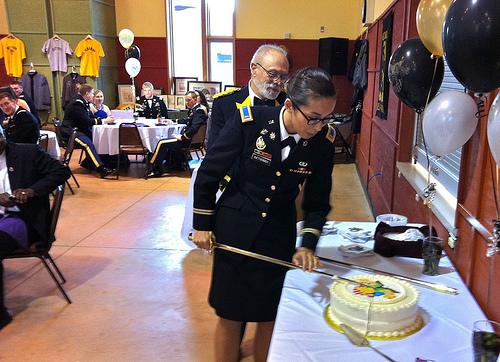How many people are seated at the tables in the picture? There are several people sitting at tables, but the exact number is unclear. What can be inferred from the presence of military personnel in the image? A group of military personnel are having a party or gathering at this event. What item is black and hanging on the wall? A black backpack is hanging on the wall. Describe the tablecloth and any additional decoration on the table. There is a white tablecloth on the table with a centerpiece made of a bouquet of helium-filled balloons. Enumerate the colors of the shirts hanging on the wall. The colors of the shirts hanging on the wall are yellow and gray. What can you tell about the woman's hair and her eyewear? The woman has her hair pulled back in a bun and is wearing black glasses. Mention the types of balloons in the image and their colors. There are black and white helium-filled balloons in the image. Discuss any visible decorations on the woman's military uniform. The woman's military uniform has gold buttons, and she has army medals displayed on her chest, signifying her status as a decorated officer. Identify the object used by the woman to cut the cake and its color. The woman is using a silver sword to cut the cake. Describe the special dessert in the image and explain why it is unique. It is a white and yellow frosted cake with a U.S. Army theme, making it unique and specific to the occasion. Can you spot the blue and green balloons floating above the dark liquid in the clear glass? No, it's not mentioned in the image. Is the man wearing a pink shirt and green shorts in the bottom-left corner of the image? There is no mention of a man wearing a pink shirt and green shorts in the image, only military personnel are mentioned. 